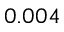<formula> <loc_0><loc_0><loc_500><loc_500>0 . 0 0 4</formula> 